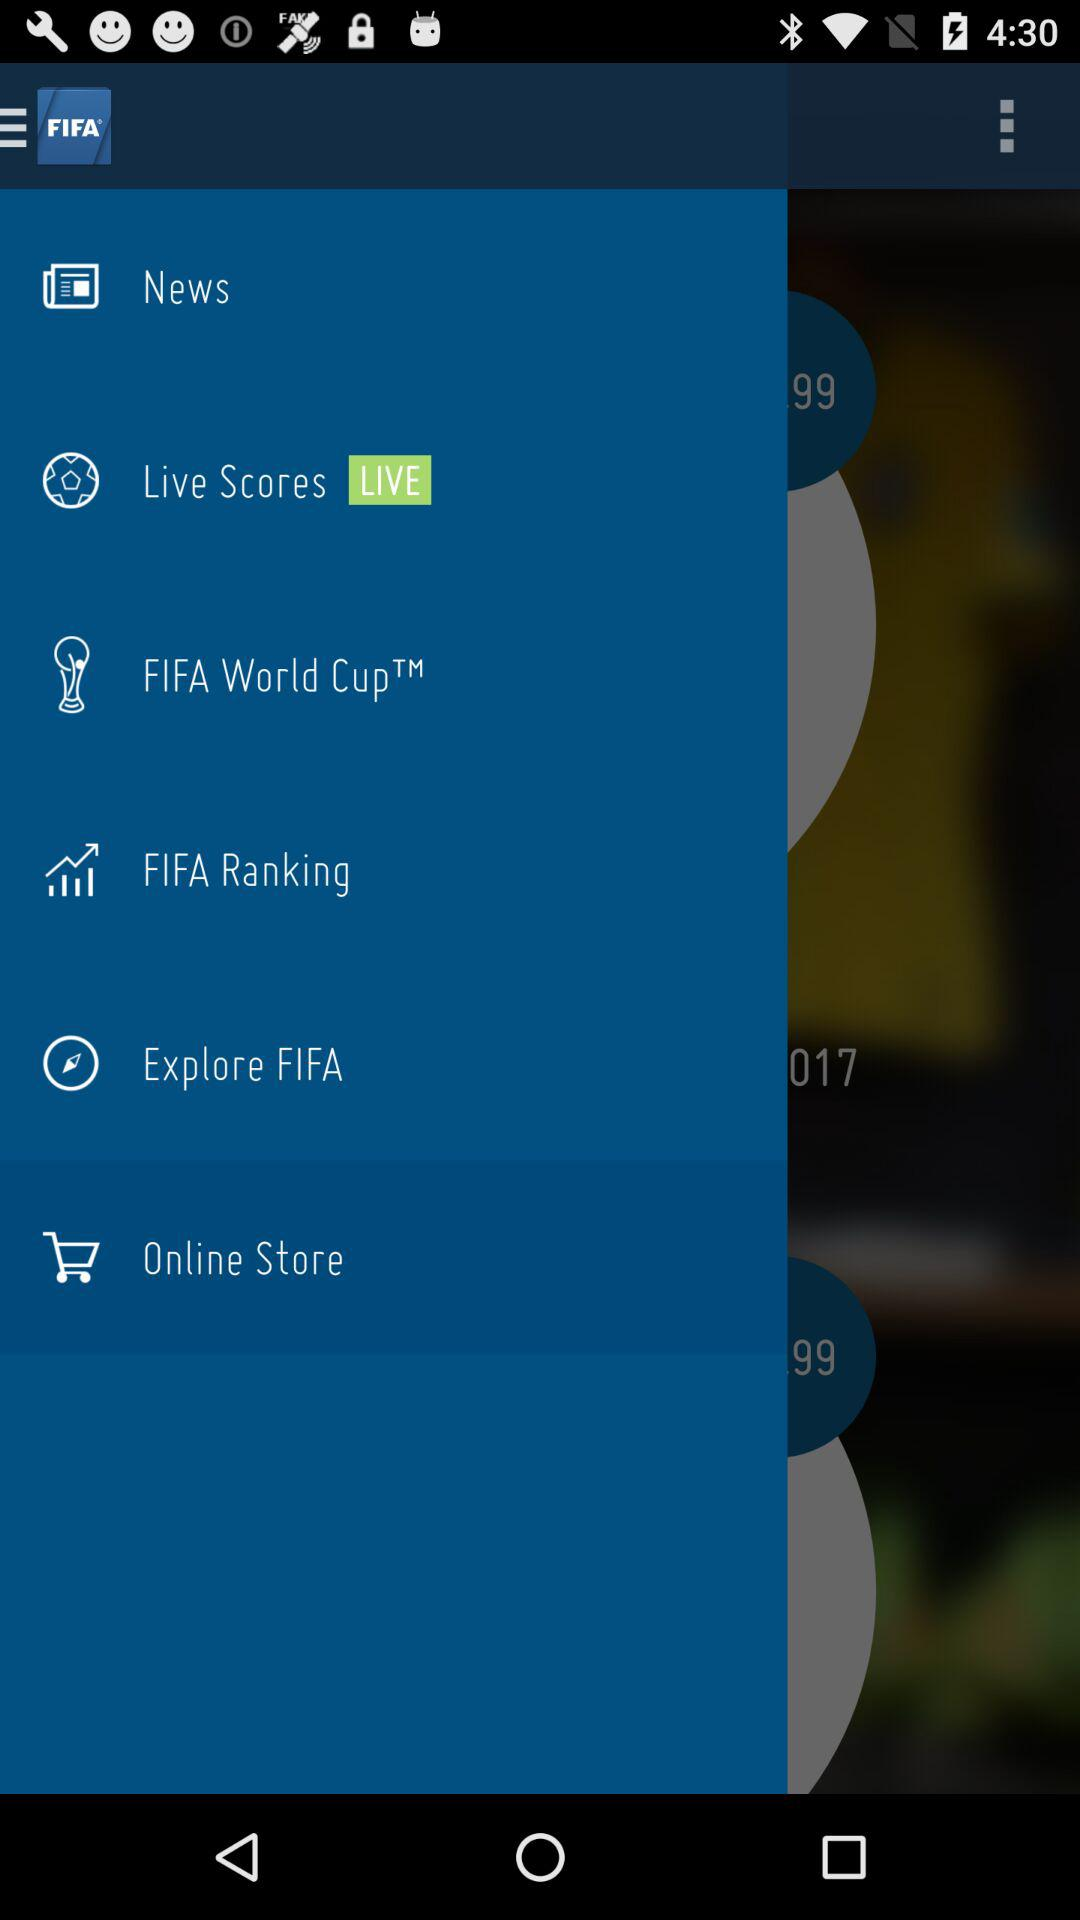What is the application name? The application name is "FIFA - Tournaments, Soccer News & Live Scores". 